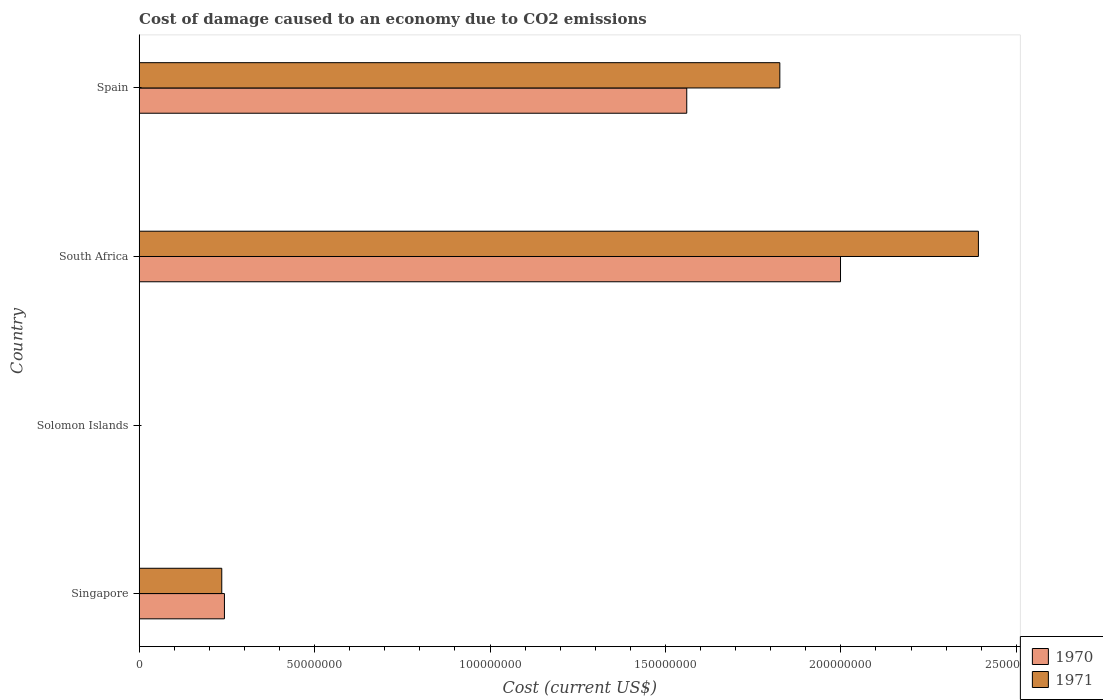How many different coloured bars are there?
Offer a terse response. 2. Are the number of bars per tick equal to the number of legend labels?
Offer a very short reply. Yes. Are the number of bars on each tick of the Y-axis equal?
Keep it short and to the point. Yes. How many bars are there on the 3rd tick from the top?
Your response must be concise. 2. How many bars are there on the 2nd tick from the bottom?
Keep it short and to the point. 2. What is the label of the 2nd group of bars from the top?
Provide a succinct answer. South Africa. In how many cases, is the number of bars for a given country not equal to the number of legend labels?
Ensure brevity in your answer.  0. What is the cost of damage caused due to CO2 emissisons in 1970 in South Africa?
Make the answer very short. 2.00e+08. Across all countries, what is the maximum cost of damage caused due to CO2 emissisons in 1970?
Offer a terse response. 2.00e+08. Across all countries, what is the minimum cost of damage caused due to CO2 emissisons in 1970?
Your answer should be compact. 5.38e+04. In which country was the cost of damage caused due to CO2 emissisons in 1970 maximum?
Give a very brief answer. South Africa. In which country was the cost of damage caused due to CO2 emissisons in 1971 minimum?
Your response must be concise. Solomon Islands. What is the total cost of damage caused due to CO2 emissisons in 1970 in the graph?
Make the answer very short. 3.80e+08. What is the difference between the cost of damage caused due to CO2 emissisons in 1971 in South Africa and that in Spain?
Provide a succinct answer. 5.66e+07. What is the difference between the cost of damage caused due to CO2 emissisons in 1970 in Singapore and the cost of damage caused due to CO2 emissisons in 1971 in Solomon Islands?
Provide a short and direct response. 2.42e+07. What is the average cost of damage caused due to CO2 emissisons in 1970 per country?
Provide a short and direct response. 9.51e+07. What is the difference between the cost of damage caused due to CO2 emissisons in 1971 and cost of damage caused due to CO2 emissisons in 1970 in Singapore?
Make the answer very short. -7.60e+05. What is the ratio of the cost of damage caused due to CO2 emissisons in 1971 in Singapore to that in Solomon Islands?
Make the answer very short. 348.08. Is the difference between the cost of damage caused due to CO2 emissisons in 1971 in Solomon Islands and South Africa greater than the difference between the cost of damage caused due to CO2 emissisons in 1970 in Solomon Islands and South Africa?
Keep it short and to the point. No. What is the difference between the highest and the second highest cost of damage caused due to CO2 emissisons in 1971?
Give a very brief answer. 5.66e+07. What is the difference between the highest and the lowest cost of damage caused due to CO2 emissisons in 1970?
Offer a very short reply. 2.00e+08. In how many countries, is the cost of damage caused due to CO2 emissisons in 1971 greater than the average cost of damage caused due to CO2 emissisons in 1971 taken over all countries?
Your answer should be very brief. 2. What does the 2nd bar from the top in Spain represents?
Ensure brevity in your answer.  1970. How many bars are there?
Make the answer very short. 8. Does the graph contain grids?
Your answer should be compact. No. How many legend labels are there?
Your answer should be compact. 2. How are the legend labels stacked?
Give a very brief answer. Vertical. What is the title of the graph?
Your response must be concise. Cost of damage caused to an economy due to CO2 emissions. Does "1993" appear as one of the legend labels in the graph?
Offer a terse response. No. What is the label or title of the X-axis?
Offer a very short reply. Cost (current US$). What is the label or title of the Y-axis?
Offer a very short reply. Country. What is the Cost (current US$) in 1970 in Singapore?
Provide a short and direct response. 2.43e+07. What is the Cost (current US$) in 1971 in Singapore?
Your response must be concise. 2.35e+07. What is the Cost (current US$) in 1970 in Solomon Islands?
Your answer should be compact. 5.38e+04. What is the Cost (current US$) in 1971 in Solomon Islands?
Provide a succinct answer. 6.76e+04. What is the Cost (current US$) in 1970 in South Africa?
Ensure brevity in your answer.  2.00e+08. What is the Cost (current US$) in 1971 in South Africa?
Your answer should be compact. 2.39e+08. What is the Cost (current US$) of 1970 in Spain?
Offer a terse response. 1.56e+08. What is the Cost (current US$) of 1971 in Spain?
Offer a terse response. 1.83e+08. Across all countries, what is the maximum Cost (current US$) of 1970?
Provide a short and direct response. 2.00e+08. Across all countries, what is the maximum Cost (current US$) in 1971?
Offer a very short reply. 2.39e+08. Across all countries, what is the minimum Cost (current US$) of 1970?
Offer a terse response. 5.38e+04. Across all countries, what is the minimum Cost (current US$) in 1971?
Your response must be concise. 6.76e+04. What is the total Cost (current US$) in 1970 in the graph?
Offer a very short reply. 3.80e+08. What is the total Cost (current US$) in 1971 in the graph?
Offer a very short reply. 4.45e+08. What is the difference between the Cost (current US$) of 1970 in Singapore and that in Solomon Islands?
Give a very brief answer. 2.43e+07. What is the difference between the Cost (current US$) in 1971 in Singapore and that in Solomon Islands?
Your answer should be compact. 2.35e+07. What is the difference between the Cost (current US$) of 1970 in Singapore and that in South Africa?
Provide a short and direct response. -1.76e+08. What is the difference between the Cost (current US$) in 1971 in Singapore and that in South Africa?
Your answer should be compact. -2.16e+08. What is the difference between the Cost (current US$) of 1970 in Singapore and that in Spain?
Provide a succinct answer. -1.32e+08. What is the difference between the Cost (current US$) of 1971 in Singapore and that in Spain?
Provide a succinct answer. -1.59e+08. What is the difference between the Cost (current US$) in 1970 in Solomon Islands and that in South Africa?
Offer a terse response. -2.00e+08. What is the difference between the Cost (current US$) of 1971 in Solomon Islands and that in South Africa?
Your answer should be very brief. -2.39e+08. What is the difference between the Cost (current US$) of 1970 in Solomon Islands and that in Spain?
Give a very brief answer. -1.56e+08. What is the difference between the Cost (current US$) in 1971 in Solomon Islands and that in Spain?
Provide a short and direct response. -1.83e+08. What is the difference between the Cost (current US$) in 1970 in South Africa and that in Spain?
Your response must be concise. 4.38e+07. What is the difference between the Cost (current US$) in 1971 in South Africa and that in Spain?
Offer a terse response. 5.66e+07. What is the difference between the Cost (current US$) in 1970 in Singapore and the Cost (current US$) in 1971 in Solomon Islands?
Give a very brief answer. 2.42e+07. What is the difference between the Cost (current US$) in 1970 in Singapore and the Cost (current US$) in 1971 in South Africa?
Keep it short and to the point. -2.15e+08. What is the difference between the Cost (current US$) of 1970 in Singapore and the Cost (current US$) of 1971 in Spain?
Provide a short and direct response. -1.58e+08. What is the difference between the Cost (current US$) of 1970 in Solomon Islands and the Cost (current US$) of 1971 in South Africa?
Ensure brevity in your answer.  -2.39e+08. What is the difference between the Cost (current US$) of 1970 in Solomon Islands and the Cost (current US$) of 1971 in Spain?
Offer a terse response. -1.83e+08. What is the difference between the Cost (current US$) in 1970 in South Africa and the Cost (current US$) in 1971 in Spain?
Offer a very short reply. 1.73e+07. What is the average Cost (current US$) in 1970 per country?
Provide a short and direct response. 9.51e+07. What is the average Cost (current US$) in 1971 per country?
Keep it short and to the point. 1.11e+08. What is the difference between the Cost (current US$) in 1970 and Cost (current US$) in 1971 in Singapore?
Provide a succinct answer. 7.60e+05. What is the difference between the Cost (current US$) in 1970 and Cost (current US$) in 1971 in Solomon Islands?
Make the answer very short. -1.38e+04. What is the difference between the Cost (current US$) of 1970 and Cost (current US$) of 1971 in South Africa?
Offer a very short reply. -3.93e+07. What is the difference between the Cost (current US$) of 1970 and Cost (current US$) of 1971 in Spain?
Your response must be concise. -2.65e+07. What is the ratio of the Cost (current US$) of 1970 in Singapore to that in Solomon Islands?
Make the answer very short. 451.45. What is the ratio of the Cost (current US$) of 1971 in Singapore to that in Solomon Islands?
Make the answer very short. 348.08. What is the ratio of the Cost (current US$) of 1970 in Singapore to that in South Africa?
Your answer should be compact. 0.12. What is the ratio of the Cost (current US$) of 1971 in Singapore to that in South Africa?
Offer a terse response. 0.1. What is the ratio of the Cost (current US$) in 1970 in Singapore to that in Spain?
Keep it short and to the point. 0.16. What is the ratio of the Cost (current US$) of 1971 in Singapore to that in Spain?
Your answer should be very brief. 0.13. What is the ratio of the Cost (current US$) in 1971 in Solomon Islands to that in South Africa?
Provide a succinct answer. 0. What is the ratio of the Cost (current US$) in 1970 in South Africa to that in Spain?
Your answer should be very brief. 1.28. What is the ratio of the Cost (current US$) in 1971 in South Africa to that in Spain?
Your answer should be compact. 1.31. What is the difference between the highest and the second highest Cost (current US$) in 1970?
Keep it short and to the point. 4.38e+07. What is the difference between the highest and the second highest Cost (current US$) in 1971?
Offer a very short reply. 5.66e+07. What is the difference between the highest and the lowest Cost (current US$) of 1970?
Ensure brevity in your answer.  2.00e+08. What is the difference between the highest and the lowest Cost (current US$) of 1971?
Offer a terse response. 2.39e+08. 